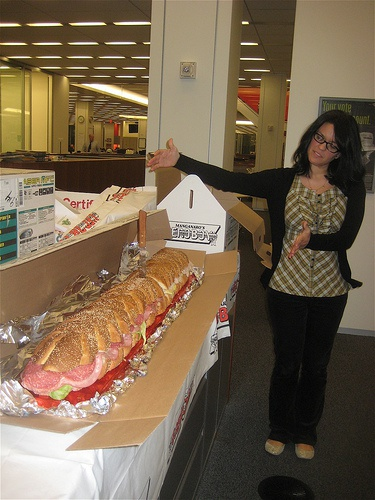Describe the objects in this image and their specific colors. I can see people in black, olive, and gray tones, sandwich in black, brown, tan, and salmon tones, and clock in black and olive tones in this image. 